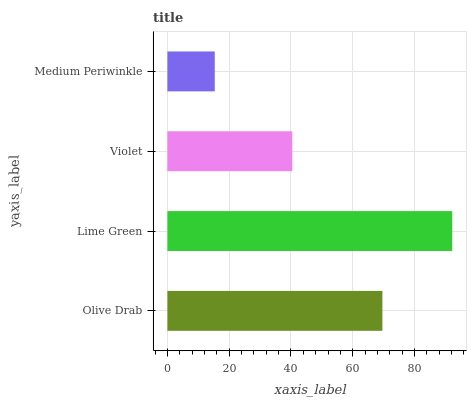Is Medium Periwinkle the minimum?
Answer yes or no. Yes. Is Lime Green the maximum?
Answer yes or no. Yes. Is Violet the minimum?
Answer yes or no. No. Is Violet the maximum?
Answer yes or no. No. Is Lime Green greater than Violet?
Answer yes or no. Yes. Is Violet less than Lime Green?
Answer yes or no. Yes. Is Violet greater than Lime Green?
Answer yes or no. No. Is Lime Green less than Violet?
Answer yes or no. No. Is Olive Drab the high median?
Answer yes or no. Yes. Is Violet the low median?
Answer yes or no. Yes. Is Lime Green the high median?
Answer yes or no. No. Is Medium Periwinkle the low median?
Answer yes or no. No. 